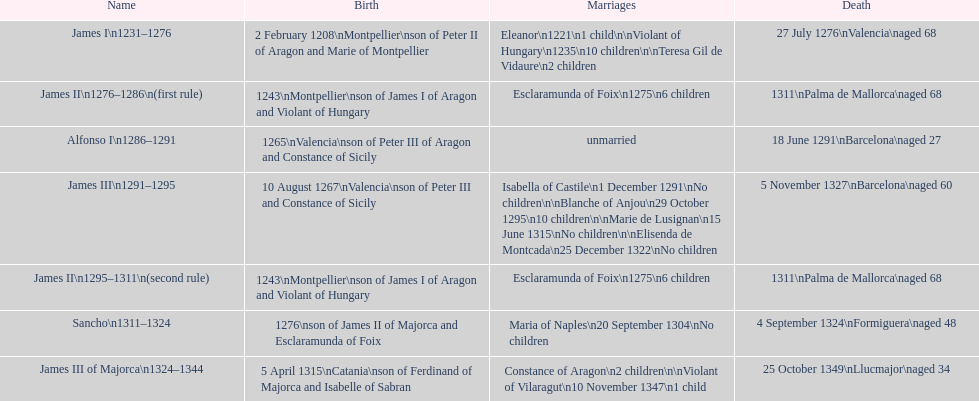Which monarch had the most marriages? James III 1291-1295. 